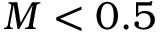Convert formula to latex. <formula><loc_0><loc_0><loc_500><loc_500>M < 0 . 5</formula> 